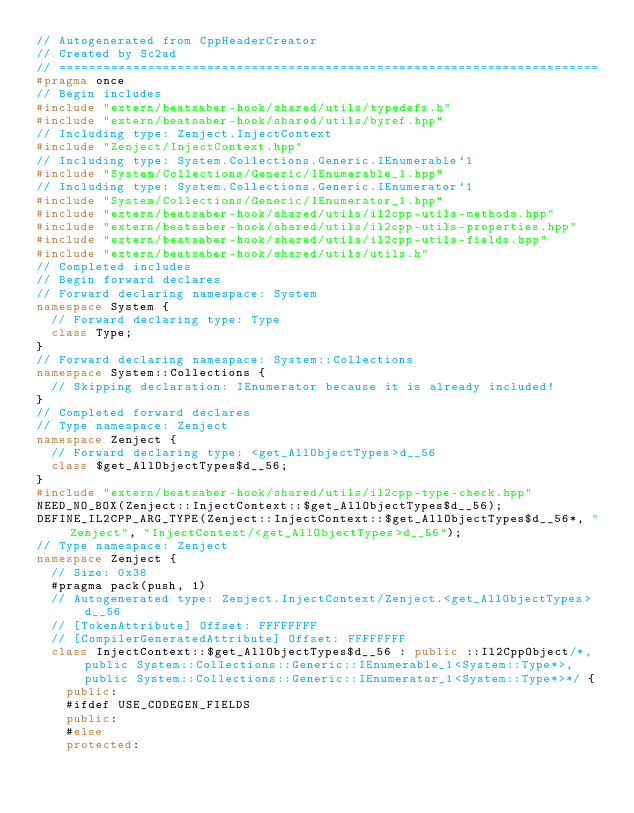<code> <loc_0><loc_0><loc_500><loc_500><_C++_>// Autogenerated from CppHeaderCreator
// Created by Sc2ad
// =========================================================================
#pragma once
// Begin includes
#include "extern/beatsaber-hook/shared/utils/typedefs.h"
#include "extern/beatsaber-hook/shared/utils/byref.hpp"
// Including type: Zenject.InjectContext
#include "Zenject/InjectContext.hpp"
// Including type: System.Collections.Generic.IEnumerable`1
#include "System/Collections/Generic/IEnumerable_1.hpp"
// Including type: System.Collections.Generic.IEnumerator`1
#include "System/Collections/Generic/IEnumerator_1.hpp"
#include "extern/beatsaber-hook/shared/utils/il2cpp-utils-methods.hpp"
#include "extern/beatsaber-hook/shared/utils/il2cpp-utils-properties.hpp"
#include "extern/beatsaber-hook/shared/utils/il2cpp-utils-fields.hpp"
#include "extern/beatsaber-hook/shared/utils/utils.h"
// Completed includes
// Begin forward declares
// Forward declaring namespace: System
namespace System {
  // Forward declaring type: Type
  class Type;
}
// Forward declaring namespace: System::Collections
namespace System::Collections {
  // Skipping declaration: IEnumerator because it is already included!
}
// Completed forward declares
// Type namespace: Zenject
namespace Zenject {
  // Forward declaring type: <get_AllObjectTypes>d__56
  class $get_AllObjectTypes$d__56;
}
#include "extern/beatsaber-hook/shared/utils/il2cpp-type-check.hpp"
NEED_NO_BOX(Zenject::InjectContext::$get_AllObjectTypes$d__56);
DEFINE_IL2CPP_ARG_TYPE(Zenject::InjectContext::$get_AllObjectTypes$d__56*, "Zenject", "InjectContext/<get_AllObjectTypes>d__56");
// Type namespace: Zenject
namespace Zenject {
  // Size: 0x38
  #pragma pack(push, 1)
  // Autogenerated type: Zenject.InjectContext/Zenject.<get_AllObjectTypes>d__56
  // [TokenAttribute] Offset: FFFFFFFF
  // [CompilerGeneratedAttribute] Offset: FFFFFFFF
  class InjectContext::$get_AllObjectTypes$d__56 : public ::Il2CppObject/*, public System::Collections::Generic::IEnumerable_1<System::Type*>, public System::Collections::Generic::IEnumerator_1<System::Type*>*/ {
    public:
    #ifdef USE_CODEGEN_FIELDS
    public:
    #else
    protected:</code> 